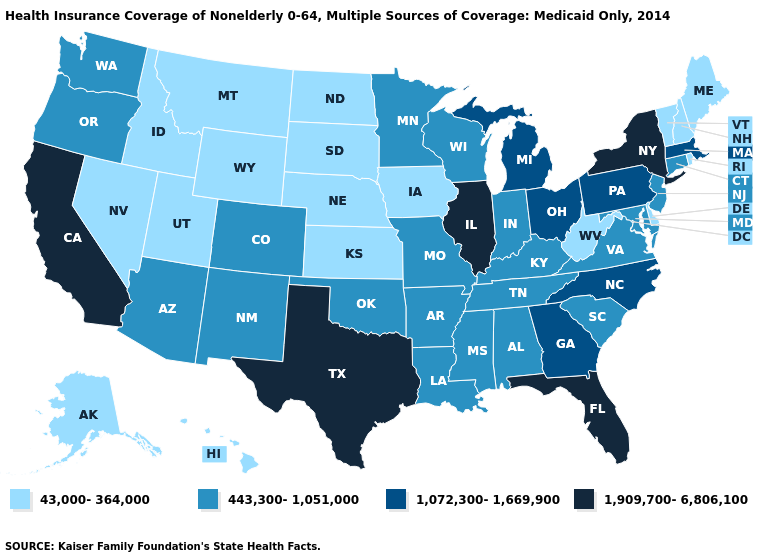What is the value of Missouri?
Write a very short answer. 443,300-1,051,000. Among the states that border California , does Oregon have the lowest value?
Quick response, please. No. What is the value of Minnesota?
Concise answer only. 443,300-1,051,000. Does the first symbol in the legend represent the smallest category?
Give a very brief answer. Yes. Which states hav the highest value in the West?
Write a very short answer. California. Does West Virginia have the lowest value in the South?
Keep it brief. Yes. Name the states that have a value in the range 1,909,700-6,806,100?
Answer briefly. California, Florida, Illinois, New York, Texas. What is the value of Georgia?
Give a very brief answer. 1,072,300-1,669,900. What is the value of Washington?
Concise answer only. 443,300-1,051,000. Which states have the lowest value in the West?
Answer briefly. Alaska, Hawaii, Idaho, Montana, Nevada, Utah, Wyoming. Which states hav the highest value in the South?
Short answer required. Florida, Texas. Does Tennessee have the lowest value in the South?
Give a very brief answer. No. Among the states that border Kansas , does Colorado have the lowest value?
Be succinct. No. Name the states that have a value in the range 1,072,300-1,669,900?
Concise answer only. Georgia, Massachusetts, Michigan, North Carolina, Ohio, Pennsylvania. 